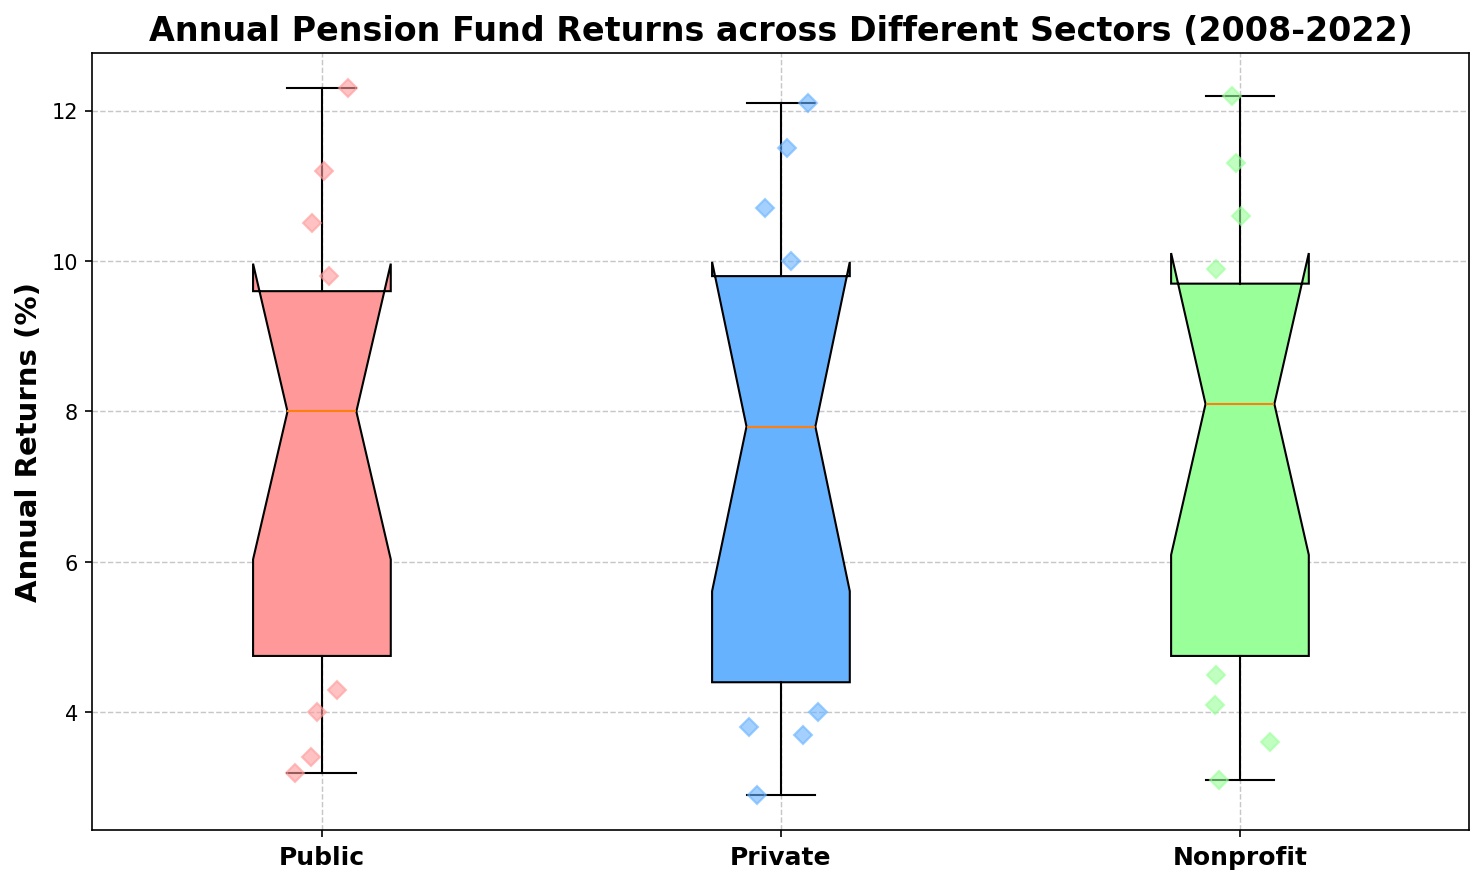Which sector has the highest median annual return? To determine the median, look at the line inside each box representing the interquartile range. The Nonprofit sector's median line is at a higher return percentage compared to the Public and Private sectors.
Answer: Nonprofit Which sector shows the widest range between the first and third quartiles? The range between the first and third quartiles is represented by the interquartile range (the height of the box). The Public sector's box is taller compared to the other sectors' boxes.
Answer: Public What is the mean annual return of the Private sector in the displayed years? Calculate the mean by summing all the annual returns of the Private sector and then dividing by the number of years. The returns are: 4.8, 6.9, 7.2, 4.0, 7.8, 12.1, 10.7, 2.9, 9.6, 9.0, 3.7, 11.5, 10.0, 8.6, 3.8. The mean is (113.6 / 15) ≈ 7.57.
Answer: 7.57 Which sector has the smallest interquartile range of annual returns? The interquartile range is represented by the height of the box in the box plot. The Nonprofit sector's box is the shortest among the three sectors.
Answer: Nonprofit What can be inferred about the variance of returns in the Public and Private sectors? Variance refers to the spread of returns. The Public sector has a taller box (higher interquartile range) and broader spread of data points which indicates higher variance compared to the Private sector which has a more confined box and data point spread.
Answer: Public sector has higher variance Which sector has the highest annual return value in the entire dataset? Identify the highest data point plotted. The highest diamond marker is in the Public sector, indicating the highest return value.
Answer: Public How do the returns of the years 2013 and 2019 compare across the sectors? For 2013, all sectors have similar high returns (around 12%). For 2019, the returns are slightly lower but still high and similar across sectors (around 11%). This indicates consistency in returns performance in these years across all sectors.
Answer: Generally similar, high returns In general, which sector displays more consistent returns over the years? Consistency in returns can be inferred from the interquartile range (IQR) and the spread of data points. The Nonprofit sector has a smaller IQR and tightly clustered data points, indicating more consistency in returns.
Answer: Nonprofit Considering the data points in 2015, how does the performance of each sector compare? Assess the annual returns for each sector in 2015: Public (3.2), Private (2.9), Nonprofit (3.1). The Public sector has the highest return, followed by Nonprofit, then Private.
Answer: Public > Nonprofit > Private What is the difference between the maximum returns of the Public and Private sectors? Identify the maximum returns in the box plots. The Public sector's maximum return is around 12.3, while the Private sector's is 12.1. The difference is 12.3 - 12.1 = 0.2.
Answer: 0.2 